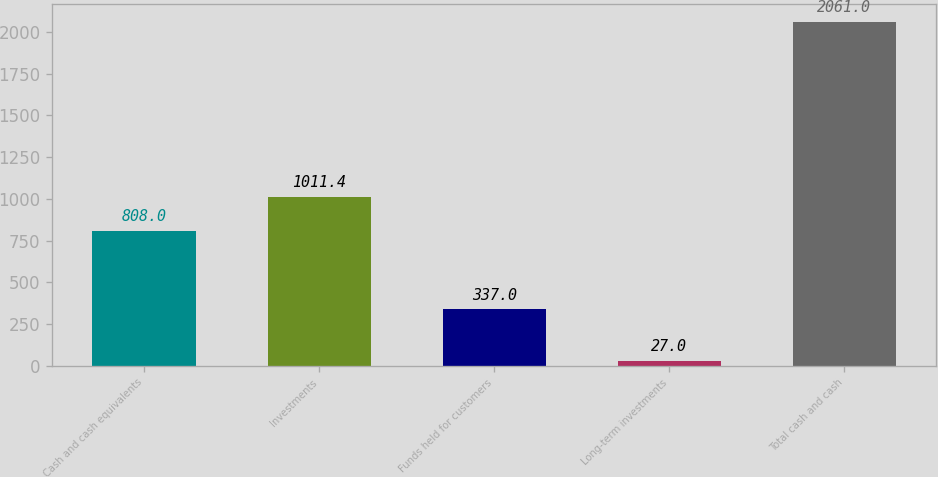Convert chart to OTSL. <chart><loc_0><loc_0><loc_500><loc_500><bar_chart><fcel>Cash and cash equivalents<fcel>Investments<fcel>Funds held for customers<fcel>Long-term investments<fcel>Total cash and cash<nl><fcel>808<fcel>1011.4<fcel>337<fcel>27<fcel>2061<nl></chart> 